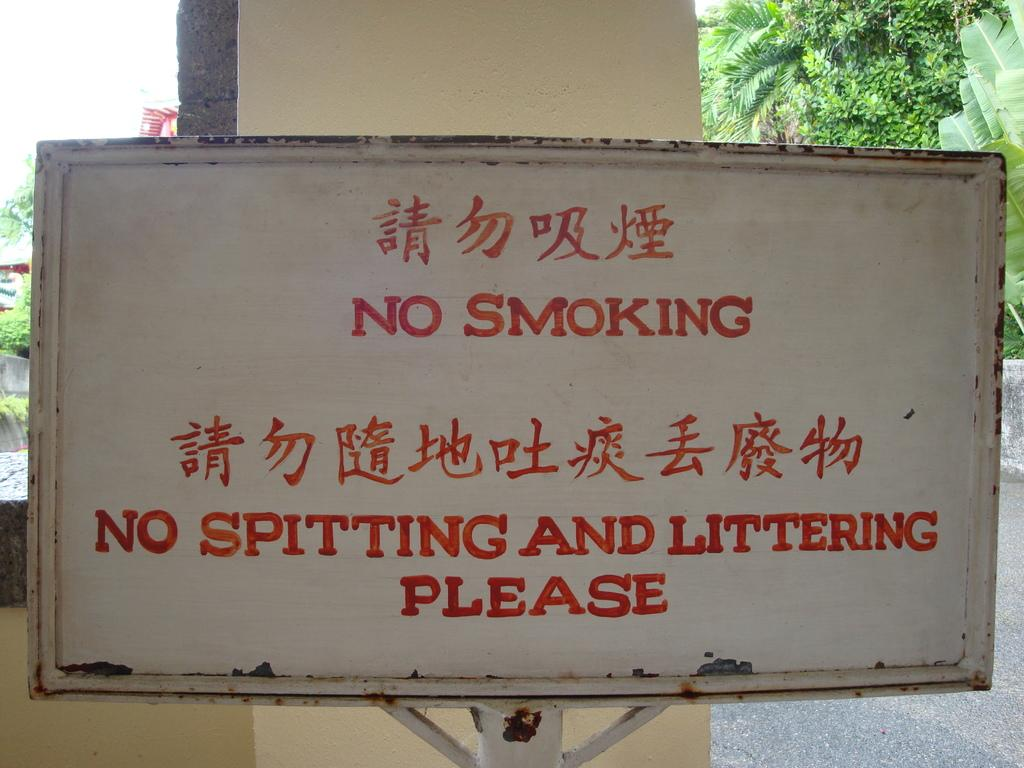What is the main object in the image? There is a whiteboard in the image. What message is displayed on the whiteboard? The whiteboard has "no smoking" written on it. What color is used for the additional writing on the whiteboard? There is something written in red color on the whiteboard. What can be seen in the background of the image? There is a wall and trees in the background of the image. What type of shelf is visible in the image? There is no shelf present in the image. What suggestion is given by the person coughing in the image? There is no person coughing in the image, and therefore no suggestion can be attributed to them. 